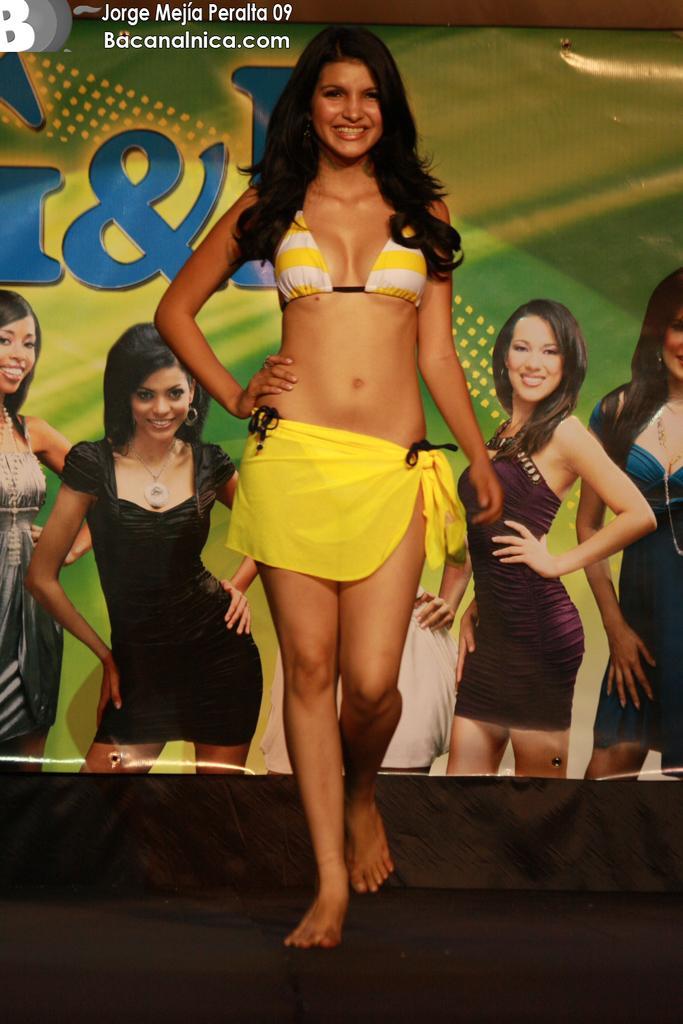How would you summarize this image in a sentence or two? In this image in front there is a person walking on the floor and she is smiling. In the background of the image there is a banner. There is some text on the top of the image. 